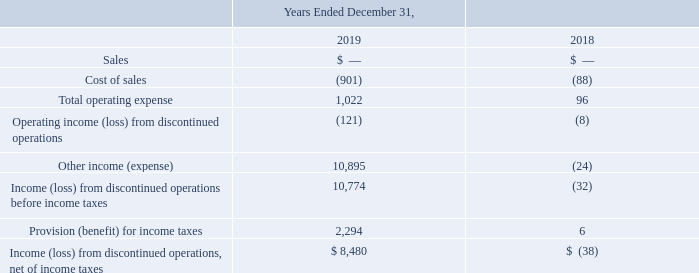Discontinued Operations
In December 2015, we completed the wind down of engineering, manufacturing and sales of our solar inverter product line (the "inverter business"). Accordingly, the results of our inverter business have been reflected as “Income (loss) from discontinued operations, net of income taxes” on our Consolidated Statements of Operations for all periods presented herein.
The effect of our sales of the remaining extended inverter warranties to our customers continues to be reflected in deferred revenue in our Consolidated Balance Sheets. Deferred revenue for extended inverter warranties and the associated costs of warranty service will be reflected in Sales and Cost of goods sold, respectively, from continuing operations in future periods in our Consolidated Statement of Operations, as the deferred revenue is earned and the associated services are rendered. Extended warranties related to the inverter product line are no longer offered.
In May 2019, we divested our grid-tied central solar inverter repair and service operation. In conjunction with the divesture, the initial product warranty for the previously sold grid-tied central solar inverters was transferred to the buyer. Accordingly, a gain of $8.6 million net of tax expense of $2.4 million was recognized in Other income (expense) and Provision (benefit) for income taxes, respectively, in our discontinued operations for the year December 31, 2019. Operating income from discontinued operations for the year ended December 31, 2019 and 2018, also includes the impacts of changes in our estimated product warranty liability, the recovery of accounts receivable and foreign exchange gain or (losses).
Income (loss) from discontinued operations, net of income taxes (in thousands):
What will the results of the company's inverter business reflect as in their Consolidated Statements of Operations? Income (loss) from discontinued operations, net of income taxes. What was the total Income (loss) from discontinued operations, net of income taxes in 2019?
Answer scale should be: thousand. 8,480. What was the total operating expense in 2018?
Answer scale should be: thousand. 96. What was the change in total operating expense between 2018 and 2019?
Answer scale should be: thousand. 1,022-96
Answer: 926. What was the change in Provision (benefit) for income taxes between 2018 and 2019?
Answer scale should be: thousand. 2,294-6
Answer: 2288. What was the percentage change in total operating expense between 2018 and 2019?
Answer scale should be: percent. (1,022-96)/96
Answer: 964.58. 